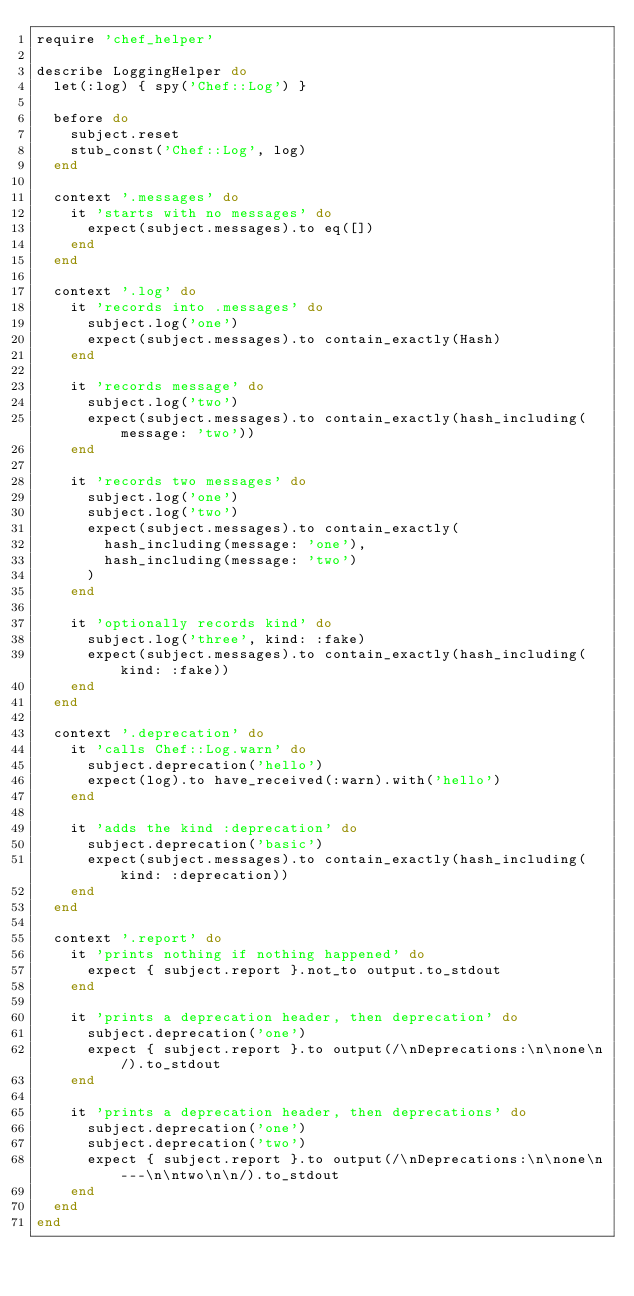<code> <loc_0><loc_0><loc_500><loc_500><_Ruby_>require 'chef_helper'

describe LoggingHelper do
  let(:log) { spy('Chef::Log') }

  before do
    subject.reset
    stub_const('Chef::Log', log)
  end

  context '.messages' do
    it 'starts with no messages' do
      expect(subject.messages).to eq([])
    end
  end

  context '.log' do
    it 'records into .messages' do
      subject.log('one')
      expect(subject.messages).to contain_exactly(Hash)
    end

    it 'records message' do
      subject.log('two')
      expect(subject.messages).to contain_exactly(hash_including(message: 'two'))
    end

    it 'records two messages' do
      subject.log('one')
      subject.log('two')
      expect(subject.messages).to contain_exactly(
        hash_including(message: 'one'),
        hash_including(message: 'two')
      )
    end

    it 'optionally records kind' do
      subject.log('three', kind: :fake)
      expect(subject.messages).to contain_exactly(hash_including(kind: :fake))
    end
  end

  context '.deprecation' do
    it 'calls Chef::Log.warn' do
      subject.deprecation('hello')
      expect(log).to have_received(:warn).with('hello')
    end

    it 'adds the kind :deprecation' do
      subject.deprecation('basic')
      expect(subject.messages).to contain_exactly(hash_including(kind: :deprecation))
    end
  end

  context '.report' do
    it 'prints nothing if nothing happened' do
      expect { subject.report }.not_to output.to_stdout
    end

    it 'prints a deprecation header, then deprecation' do
      subject.deprecation('one')
      expect { subject.report }.to output(/\nDeprecations:\n\none\n/).to_stdout
    end

    it 'prints a deprecation header, then deprecations' do
      subject.deprecation('one')
      subject.deprecation('two')
      expect { subject.report }.to output(/\nDeprecations:\n\none\n---\n\ntwo\n\n/).to_stdout
    end
  end
end
</code> 